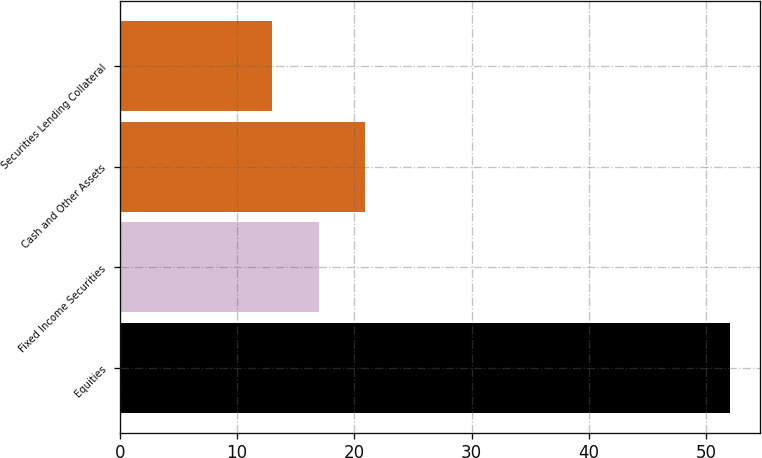Convert chart. <chart><loc_0><loc_0><loc_500><loc_500><bar_chart><fcel>Equities<fcel>Fixed Income Securities<fcel>Cash and Other Assets<fcel>Securities Lending Collateral<nl><fcel>52<fcel>17<fcel>20.9<fcel>13<nl></chart> 